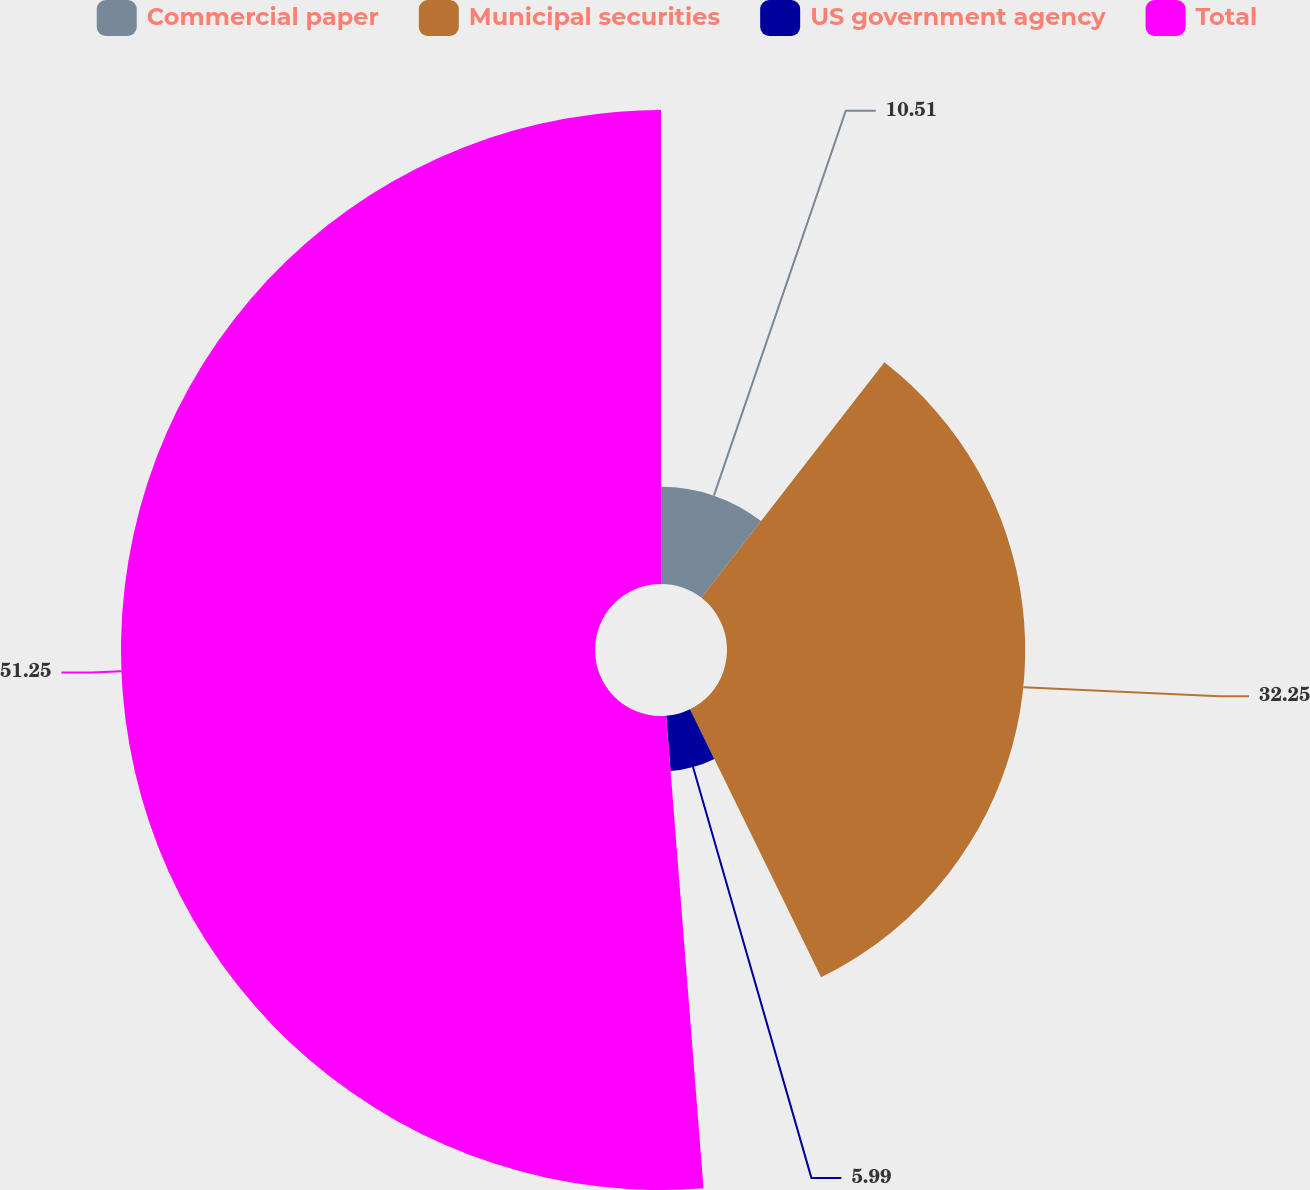<chart> <loc_0><loc_0><loc_500><loc_500><pie_chart><fcel>Commercial paper<fcel>Municipal securities<fcel>US government agency<fcel>Total<nl><fcel>10.51%<fcel>32.25%<fcel>5.99%<fcel>51.26%<nl></chart> 